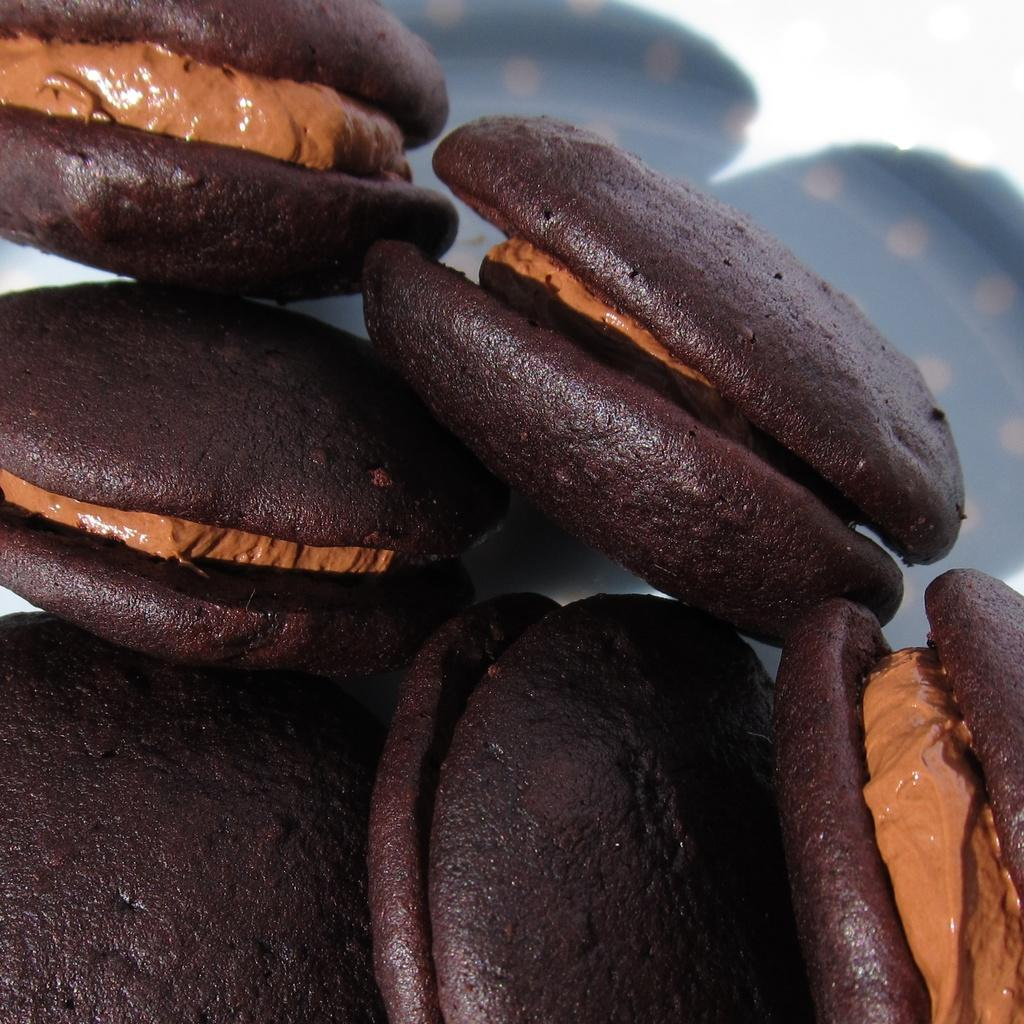What type of food item can be seen in the image? There is a food item in the image that looks like cookies. What type of wax is used to make the cookies in the image? There is no mention of wax or any wax-related process in the image or the provided facts. 